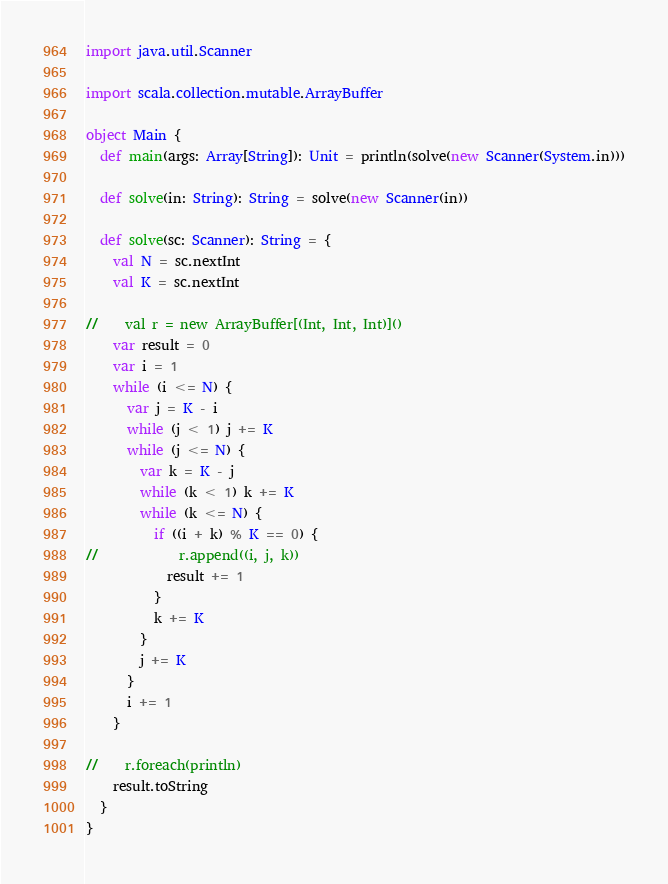<code> <loc_0><loc_0><loc_500><loc_500><_Scala_>import java.util.Scanner

import scala.collection.mutable.ArrayBuffer

object Main {
  def main(args: Array[String]): Unit = println(solve(new Scanner(System.in)))

  def solve(in: String): String = solve(new Scanner(in))

  def solve(sc: Scanner): String = {
    val N = sc.nextInt
    val K = sc.nextInt

//    val r = new ArrayBuffer[(Int, Int, Int)]()
    var result = 0
    var i = 1
    while (i <= N) {
      var j = K - i
      while (j < 1) j += K
      while (j <= N) {
        var k = K - j
        while (k < 1) k += K
        while (k <= N) {
          if ((i + k) % K == 0) {
//            r.append((i, j, k))
            result += 1
          }
          k += K
        }
        j += K
      }
      i += 1
    }

//    r.foreach(println)
    result.toString
  }
}
</code> 